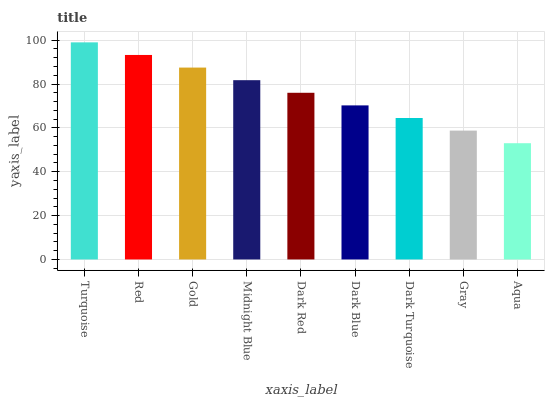Is Red the minimum?
Answer yes or no. No. Is Red the maximum?
Answer yes or no. No. Is Turquoise greater than Red?
Answer yes or no. Yes. Is Red less than Turquoise?
Answer yes or no. Yes. Is Red greater than Turquoise?
Answer yes or no. No. Is Turquoise less than Red?
Answer yes or no. No. Is Dark Red the high median?
Answer yes or no. Yes. Is Dark Red the low median?
Answer yes or no. Yes. Is Dark Blue the high median?
Answer yes or no. No. Is Dark Blue the low median?
Answer yes or no. No. 